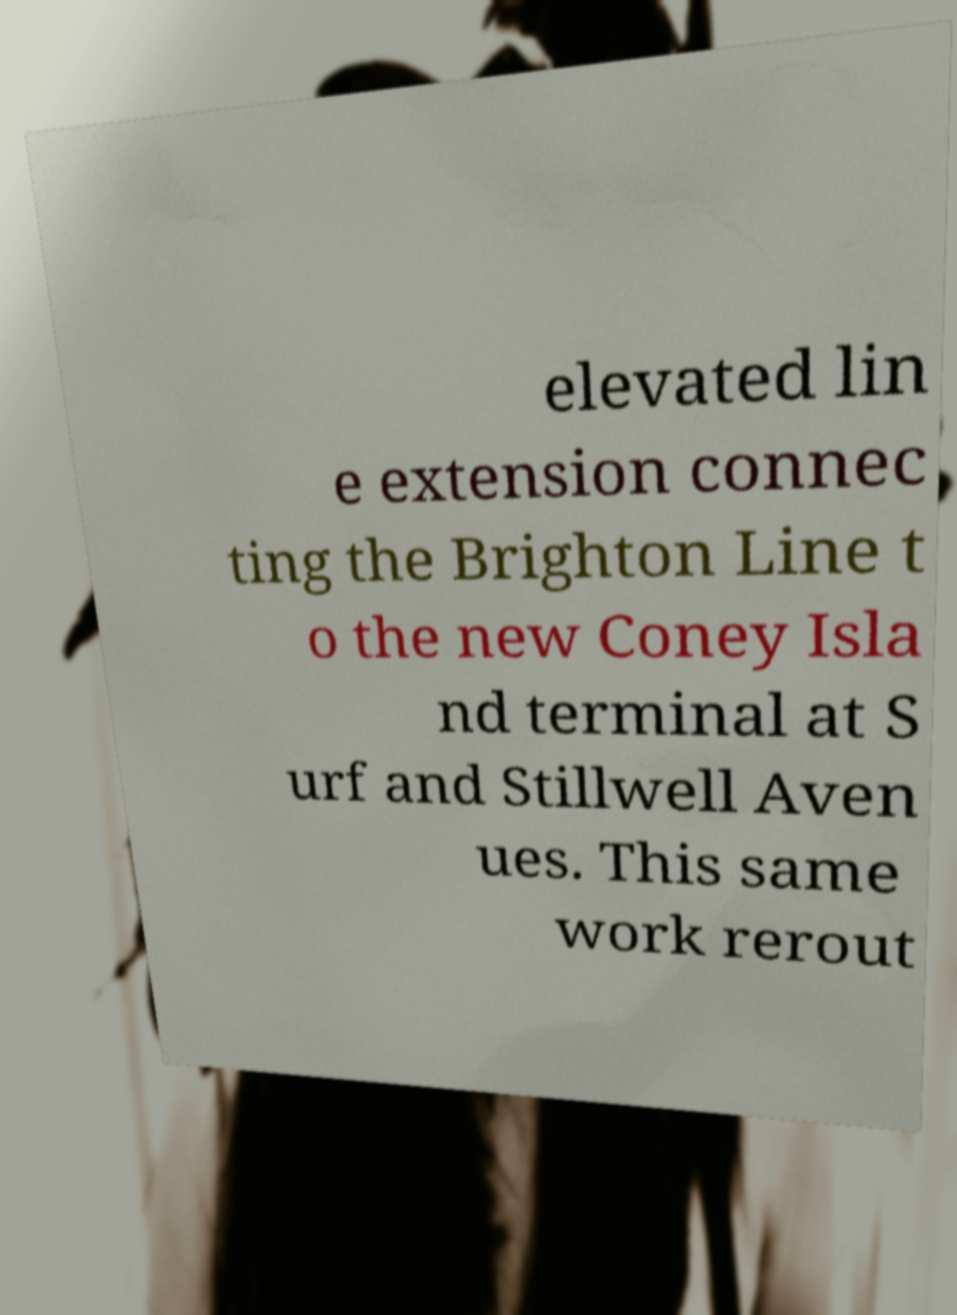Can you read and provide the text displayed in the image?This photo seems to have some interesting text. Can you extract and type it out for me? elevated lin e extension connec ting the Brighton Line t o the new Coney Isla nd terminal at S urf and Stillwell Aven ues. This same work rerout 